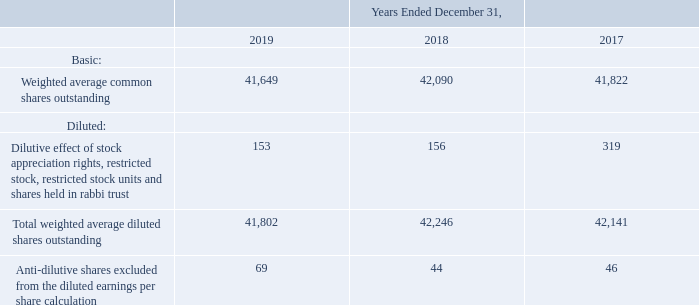Note 21. Earnings Per Share
Basic earnings per share are based on the weighted average number of common shares outstanding during the periods. Diluted earnings per share includes the weighted average number of common shares outstanding during the respective periods and the further dilutive effect, if any, from stock appreciation rights, restricted stock, restricted stock units and shares held in rabbi trust using the treasury stock method.
The number of shares used in the earnings per share computation were as follows (in thousands):
What is the number of Basic Weighted average common shares outstanding in 2019?
Answer scale should be: thousand. 41,649. What is the number of Total weighted average diluted shares outstanding in 2018?
Answer scale should be: thousand. 42,246. In which years is the Total weighted average diluted shares outstanding calculated? 2019, 2018, 2017. In which year was the Anti-dilutive shares excluded from the diluted earnings per share calculation largest? 69>46>46
Answer: 2019. What was the change in the Anti-dilutive shares excluded from the diluted earnings per share calculation in 2019 from 2018?
Answer scale should be: thousand. 69-44
Answer: 25. What was the percentage change in the Anti-dilutive shares excluded from the diluted earnings per share calculation in 2019 from 2018?
Answer scale should be: percent. (69-44)/44
Answer: 56.82. 